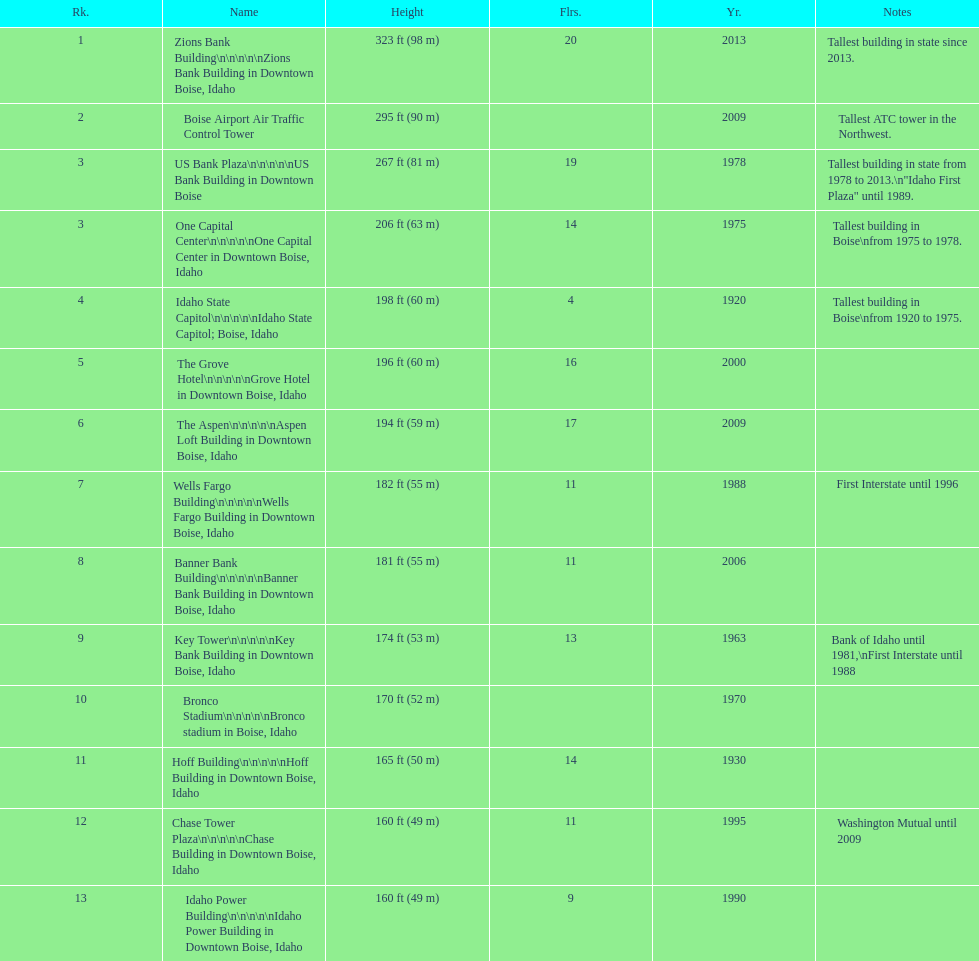Would you mind parsing the complete table? {'header': ['Rk.', 'Name', 'Height', 'Flrs.', 'Yr.', 'Notes'], 'rows': [['1', 'Zions Bank Building\\n\\n\\n\\n\\nZions Bank Building in Downtown Boise, Idaho', '323\xa0ft (98\xa0m)', '20', '2013', 'Tallest building in state since 2013.'], ['2', 'Boise Airport Air Traffic Control Tower', '295\xa0ft (90\xa0m)', '', '2009', 'Tallest ATC tower in the Northwest.'], ['3', 'US Bank Plaza\\n\\n\\n\\n\\nUS Bank Building in Downtown Boise', '267\xa0ft (81\xa0m)', '19', '1978', 'Tallest building in state from 1978 to 2013.\\n"Idaho First Plaza" until 1989.'], ['3', 'One Capital Center\\n\\n\\n\\n\\nOne Capital Center in Downtown Boise, Idaho', '206\xa0ft (63\xa0m)', '14', '1975', 'Tallest building in Boise\\nfrom 1975 to 1978.'], ['4', 'Idaho State Capitol\\n\\n\\n\\n\\nIdaho State Capitol; Boise, Idaho', '198\xa0ft (60\xa0m)', '4', '1920', 'Tallest building in Boise\\nfrom 1920 to 1975.'], ['5', 'The Grove Hotel\\n\\n\\n\\n\\nGrove Hotel in Downtown Boise, Idaho', '196\xa0ft (60\xa0m)', '16', '2000', ''], ['6', 'The Aspen\\n\\n\\n\\n\\nAspen Loft Building in Downtown Boise, Idaho', '194\xa0ft (59\xa0m)', '17', '2009', ''], ['7', 'Wells Fargo Building\\n\\n\\n\\n\\nWells Fargo Building in Downtown Boise, Idaho', '182\xa0ft (55\xa0m)', '11', '1988', 'First Interstate until 1996'], ['8', 'Banner Bank Building\\n\\n\\n\\n\\nBanner Bank Building in Downtown Boise, Idaho', '181\xa0ft (55\xa0m)', '11', '2006', ''], ['9', 'Key Tower\\n\\n\\n\\n\\nKey Bank Building in Downtown Boise, Idaho', '174\xa0ft (53\xa0m)', '13', '1963', 'Bank of Idaho until 1981,\\nFirst Interstate until 1988'], ['10', 'Bronco Stadium\\n\\n\\n\\n\\nBronco stadium in Boise, Idaho', '170\xa0ft (52\xa0m)', '', '1970', ''], ['11', 'Hoff Building\\n\\n\\n\\n\\nHoff Building in Downtown Boise, Idaho', '165\xa0ft (50\xa0m)', '14', '1930', ''], ['12', 'Chase Tower Plaza\\n\\n\\n\\n\\nChase Building in Downtown Boise, Idaho', '160\xa0ft (49\xa0m)', '11', '1995', 'Washington Mutual until 2009'], ['13', 'Idaho Power Building\\n\\n\\n\\n\\nIdaho Power Building in Downtown Boise, Idaho', '160\xa0ft (49\xa0m)', '9', '1990', '']]} How many floors does the tallest building have? 20. 